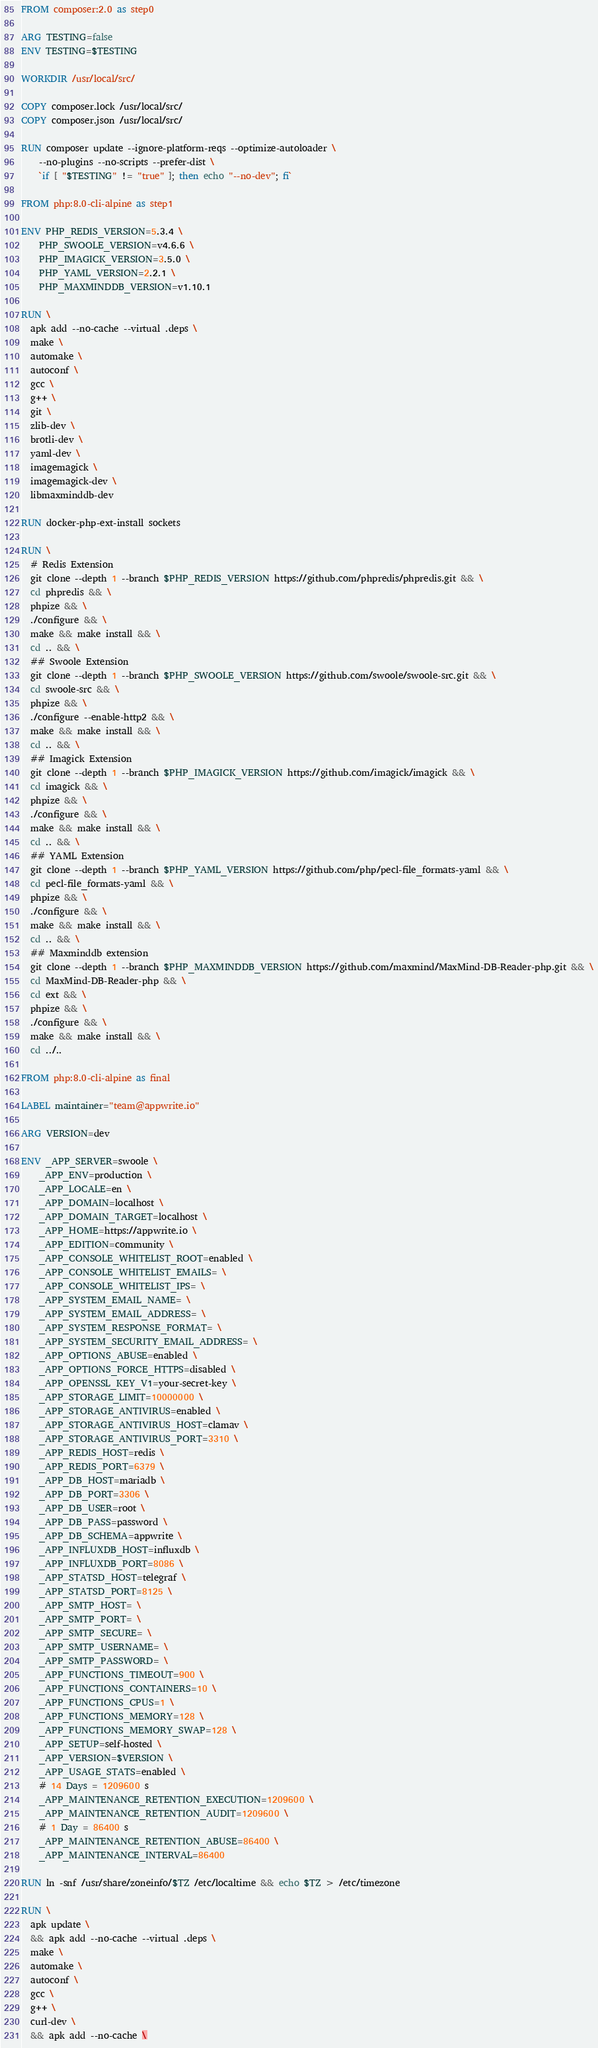<code> <loc_0><loc_0><loc_500><loc_500><_Dockerfile_>FROM composer:2.0 as step0

ARG TESTING=false
ENV TESTING=$TESTING

WORKDIR /usr/local/src/

COPY composer.lock /usr/local/src/
COPY composer.json /usr/local/src/

RUN composer update --ignore-platform-reqs --optimize-autoloader \
    --no-plugins --no-scripts --prefer-dist \
    `if [ "$TESTING" != "true" ]; then echo "--no-dev"; fi`

FROM php:8.0-cli-alpine as step1

ENV PHP_REDIS_VERSION=5.3.4 \
    PHP_SWOOLE_VERSION=v4.6.6 \
    PHP_IMAGICK_VERSION=3.5.0 \
    PHP_YAML_VERSION=2.2.1 \
    PHP_MAXMINDDB_VERSION=v1.10.1

RUN \
  apk add --no-cache --virtual .deps \
  make \
  automake \
  autoconf \
  gcc \
  g++ \
  git \
  zlib-dev \
  brotli-dev \
  yaml-dev \
  imagemagick \
  imagemagick-dev \
  libmaxminddb-dev

RUN docker-php-ext-install sockets

RUN \
  # Redis Extension
  git clone --depth 1 --branch $PHP_REDIS_VERSION https://github.com/phpredis/phpredis.git && \
  cd phpredis && \
  phpize && \
  ./configure && \
  make && make install && \
  cd .. && \
  ## Swoole Extension
  git clone --depth 1 --branch $PHP_SWOOLE_VERSION https://github.com/swoole/swoole-src.git && \
  cd swoole-src && \
  phpize && \
  ./configure --enable-http2 && \
  make && make install && \
  cd .. && \
  ## Imagick Extension
  git clone --depth 1 --branch $PHP_IMAGICK_VERSION https://github.com/imagick/imagick && \
  cd imagick && \
  phpize && \
  ./configure && \
  make && make install && \
  cd .. && \
  ## YAML Extension
  git clone --depth 1 --branch $PHP_YAML_VERSION https://github.com/php/pecl-file_formats-yaml && \
  cd pecl-file_formats-yaml && \
  phpize && \
  ./configure && \
  make && make install && \
  cd .. && \
  ## Maxminddb extension
  git clone --depth 1 --branch $PHP_MAXMINDDB_VERSION https://github.com/maxmind/MaxMind-DB-Reader-php.git && \
  cd MaxMind-DB-Reader-php && \
  cd ext && \
  phpize && \
  ./configure && \
  make && make install && \
  cd ../..

FROM php:8.0-cli-alpine as final

LABEL maintainer="team@appwrite.io"

ARG VERSION=dev

ENV _APP_SERVER=swoole \
    _APP_ENV=production \
    _APP_LOCALE=en \
    _APP_DOMAIN=localhost \
    _APP_DOMAIN_TARGET=localhost \
    _APP_HOME=https://appwrite.io \
    _APP_EDITION=community \
    _APP_CONSOLE_WHITELIST_ROOT=enabled \
    _APP_CONSOLE_WHITELIST_EMAILS= \
    _APP_CONSOLE_WHITELIST_IPS= \
    _APP_SYSTEM_EMAIL_NAME= \
    _APP_SYSTEM_EMAIL_ADDRESS= \
    _APP_SYSTEM_RESPONSE_FORMAT= \
    _APP_SYSTEM_SECURITY_EMAIL_ADDRESS= \
    _APP_OPTIONS_ABUSE=enabled \
    _APP_OPTIONS_FORCE_HTTPS=disabled \
    _APP_OPENSSL_KEY_V1=your-secret-key \
    _APP_STORAGE_LIMIT=10000000 \
    _APP_STORAGE_ANTIVIRUS=enabled \
    _APP_STORAGE_ANTIVIRUS_HOST=clamav \
    _APP_STORAGE_ANTIVIRUS_PORT=3310 \
    _APP_REDIS_HOST=redis \
    _APP_REDIS_PORT=6379 \
    _APP_DB_HOST=mariadb \
    _APP_DB_PORT=3306 \
    _APP_DB_USER=root \
    _APP_DB_PASS=password \
    _APP_DB_SCHEMA=appwrite \
    _APP_INFLUXDB_HOST=influxdb \
    _APP_INFLUXDB_PORT=8086 \
    _APP_STATSD_HOST=telegraf \
    _APP_STATSD_PORT=8125 \
    _APP_SMTP_HOST= \
    _APP_SMTP_PORT= \
    _APP_SMTP_SECURE= \
    _APP_SMTP_USERNAME= \
    _APP_SMTP_PASSWORD= \
    _APP_FUNCTIONS_TIMEOUT=900 \
    _APP_FUNCTIONS_CONTAINERS=10 \
    _APP_FUNCTIONS_CPUS=1 \
    _APP_FUNCTIONS_MEMORY=128 \
    _APP_FUNCTIONS_MEMORY_SWAP=128 \
    _APP_SETUP=self-hosted \
    _APP_VERSION=$VERSION \
    _APP_USAGE_STATS=enabled \
    # 14 Days = 1209600 s
    _APP_MAINTENANCE_RETENTION_EXECUTION=1209600 \
    _APP_MAINTENANCE_RETENTION_AUDIT=1209600 \
    # 1 Day = 86400 s
    _APP_MAINTENANCE_RETENTION_ABUSE=86400 \
    _APP_MAINTENANCE_INTERVAL=86400

RUN ln -snf /usr/share/zoneinfo/$TZ /etc/localtime && echo $TZ > /etc/timezone

RUN \
  apk update \
  && apk add --no-cache --virtual .deps \
  make \
  automake \
  autoconf \
  gcc \
  g++ \
  curl-dev \
  && apk add --no-cache \</code> 